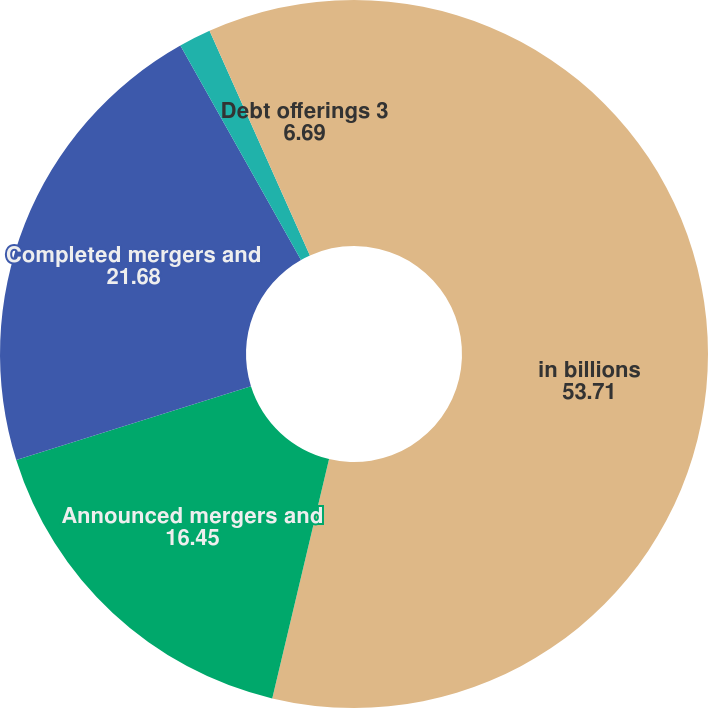<chart> <loc_0><loc_0><loc_500><loc_500><pie_chart><fcel>in billions<fcel>Announced mergers and<fcel>Completed mergers and<fcel>Equity and equity-related<fcel>Debt offerings 3<nl><fcel>53.71%<fcel>16.45%<fcel>21.68%<fcel>1.47%<fcel>6.69%<nl></chart> 